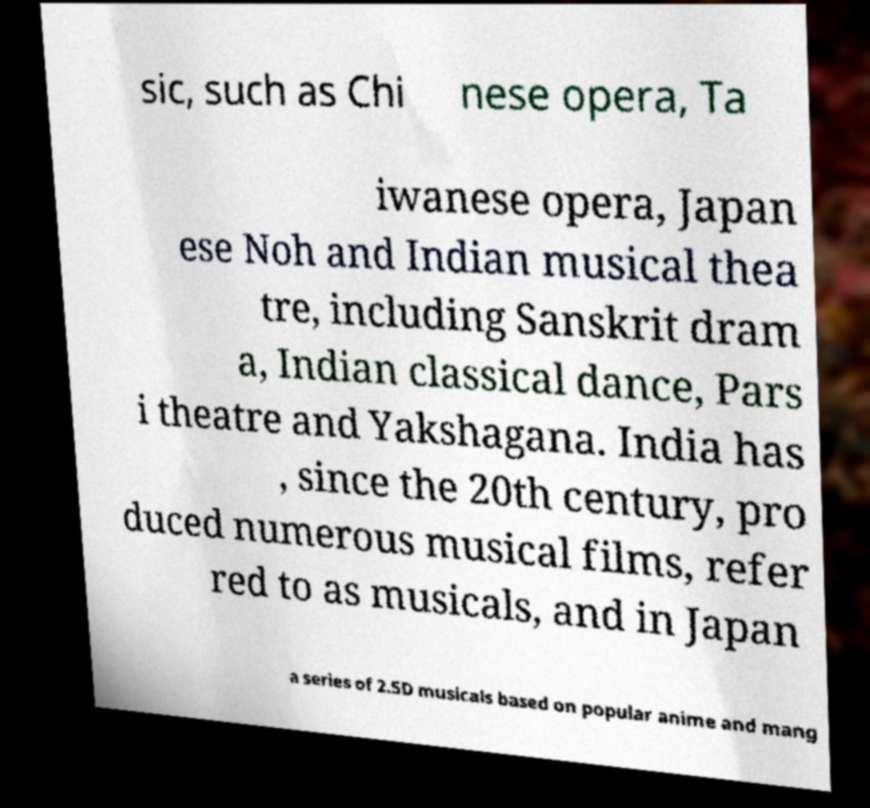Can you read and provide the text displayed in the image?This photo seems to have some interesting text. Can you extract and type it out for me? sic, such as Chi nese opera, Ta iwanese opera, Japan ese Noh and Indian musical thea tre, including Sanskrit dram a, Indian classical dance, Pars i theatre and Yakshagana. India has , since the 20th century, pro duced numerous musical films, refer red to as musicals, and in Japan a series of 2.5D musicals based on popular anime and mang 